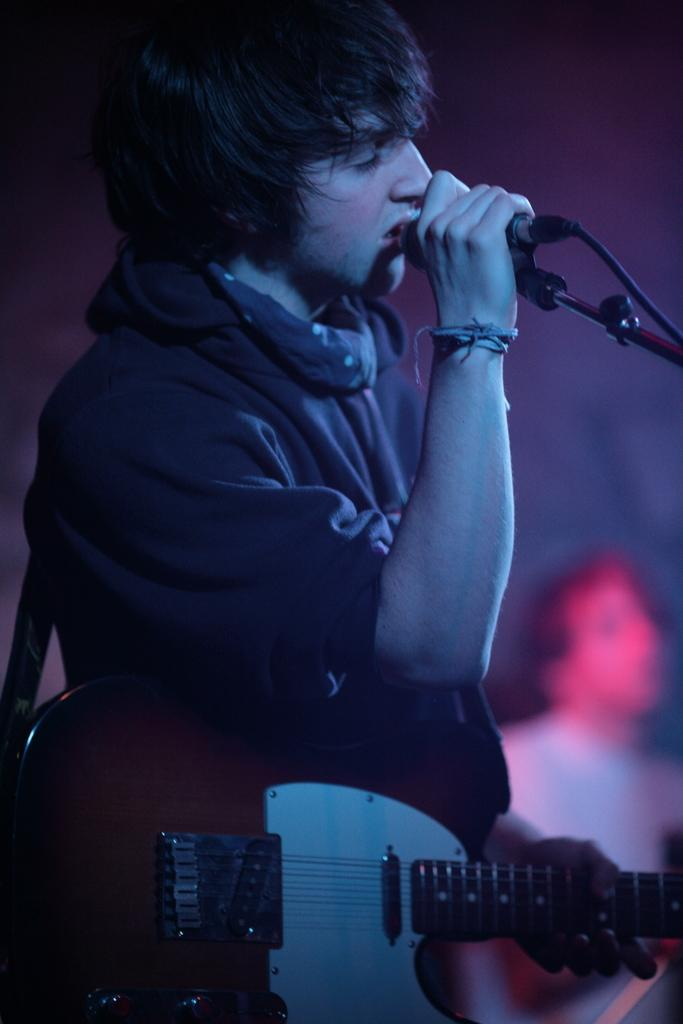What is the person in the image holding in their right hand? The person is holding a microphone in their right hand. What instrument is the person playing in the image? The person is holding a guitar with their left hand. Can you describe the other person in the image? There is another person in the background of the image, but no specific details are provided about them. What type of order is the person holding the microphone giving in the image? There is no indication of any order being given in the image. 